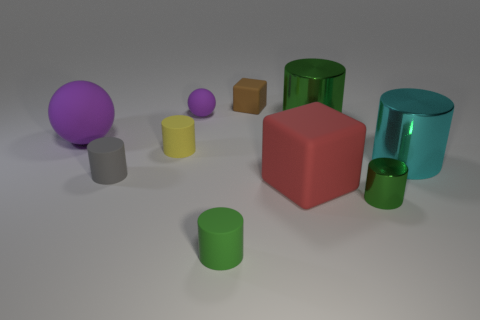Subtract all brown balls. How many green cylinders are left? 3 Subtract all yellow cylinders. How many cylinders are left? 5 Subtract all yellow cylinders. How many cylinders are left? 5 Subtract all brown cylinders. Subtract all green balls. How many cylinders are left? 6 Subtract all cylinders. How many objects are left? 4 Subtract 0 red balls. How many objects are left? 10 Subtract all purple matte things. Subtract all rubber cylinders. How many objects are left? 5 Add 3 small green cylinders. How many small green cylinders are left? 5 Add 7 big cyan cylinders. How many big cyan cylinders exist? 8 